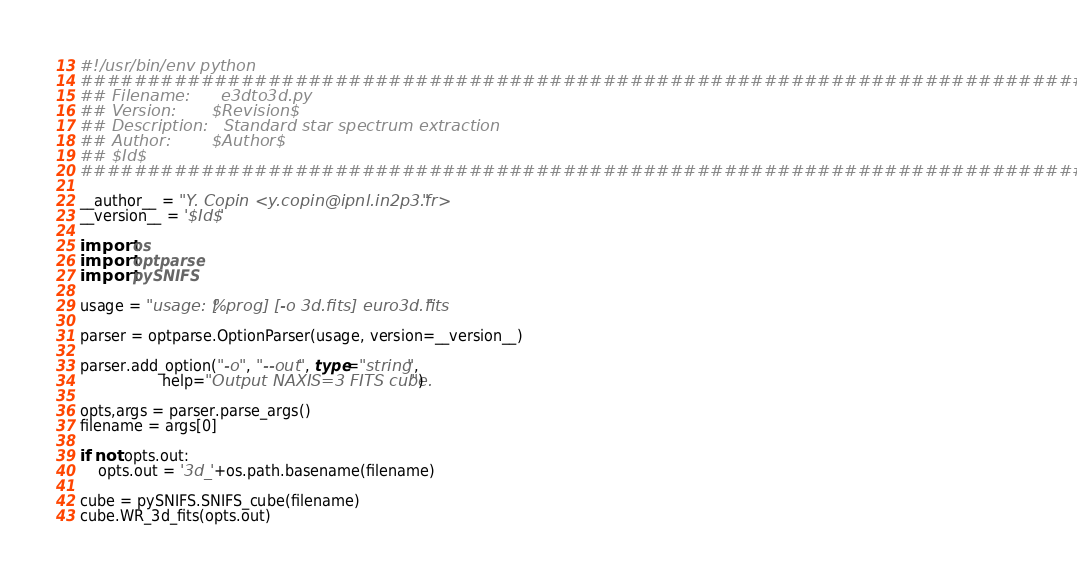<code> <loc_0><loc_0><loc_500><loc_500><_Python_>#!/usr/bin/env python
##############################################################################
## Filename:      e3dto3d.py
## Version:       $Revision$
## Description:   Standard star spectrum extraction
## Author:        $Author$
## $Id$
##############################################################################

__author__ = "Y. Copin <y.copin@ipnl.in2p3.fr>"
__version__ = '$Id$'

import os
import optparse
import pySNIFS

usage = "usage: [%prog] [-o 3d.fits] euro3d.fits"

parser = optparse.OptionParser(usage, version=__version__)

parser.add_option("-o", "--out", type="string",
                  help="Output NAXIS=3 FITS cube.")

opts,args = parser.parse_args()
filename = args[0]

if not opts.out:
    opts.out = '3d_'+os.path.basename(filename)

cube = pySNIFS.SNIFS_cube(filename)
cube.WR_3d_fits(opts.out)
</code> 